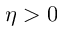<formula> <loc_0><loc_0><loc_500><loc_500>\eta > 0</formula> 